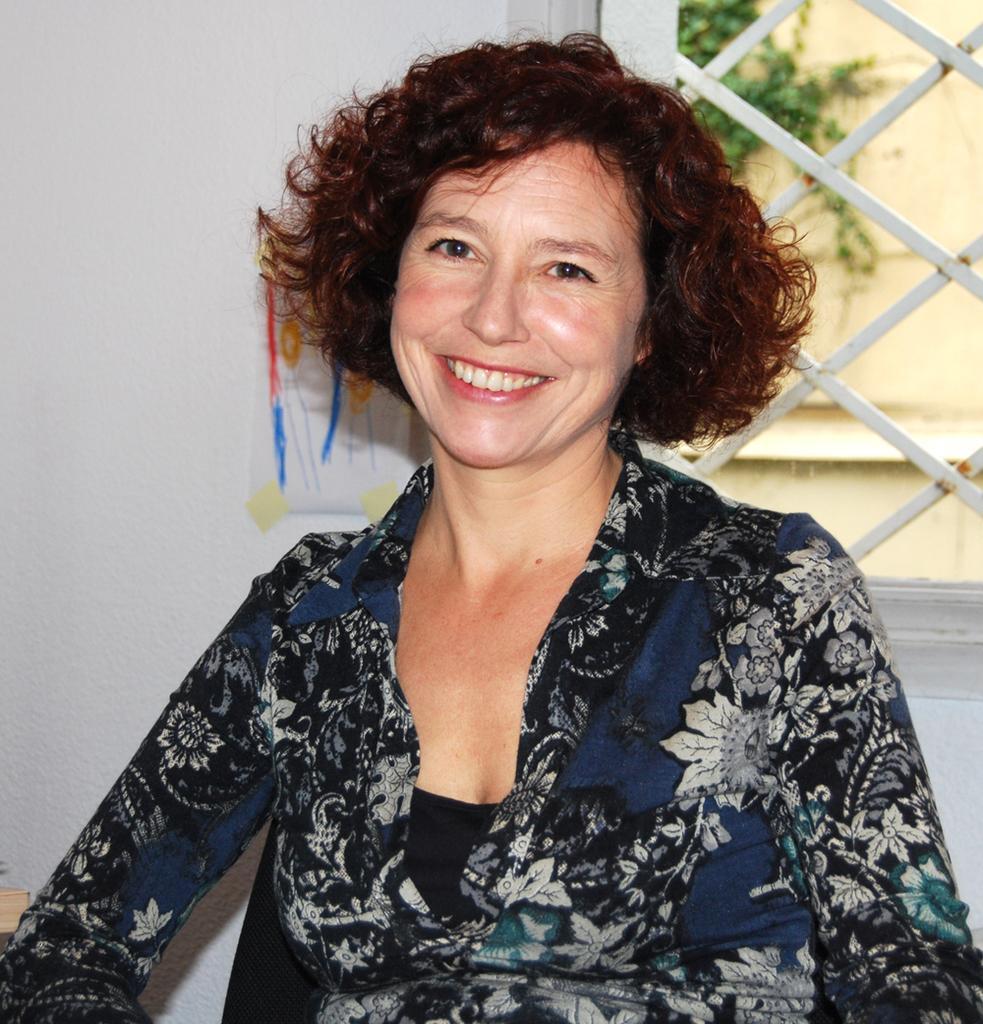Could you give a brief overview of what you see in this image? In this image, we can see a person. In the background, we can see the wall with an object and a window. We can also see a plant. 